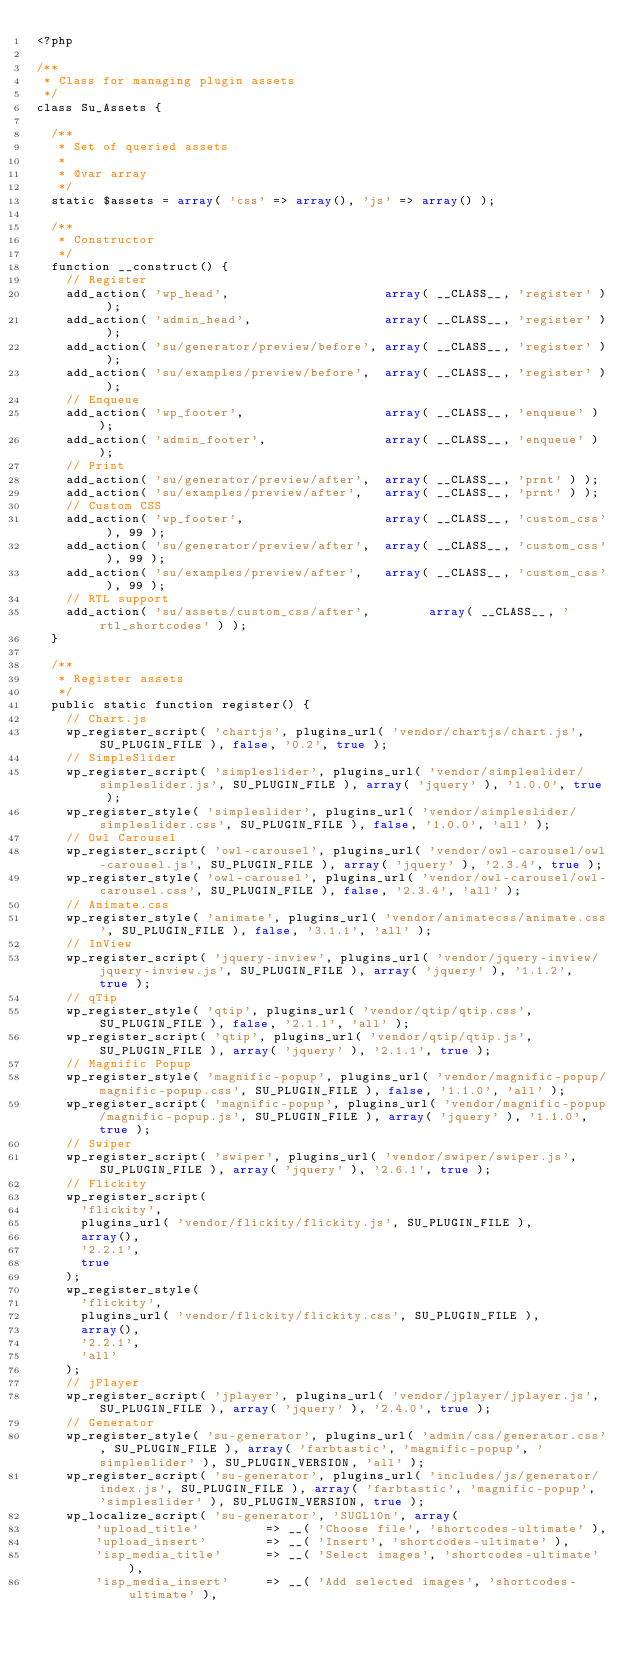<code> <loc_0><loc_0><loc_500><loc_500><_PHP_><?php

/**
 * Class for managing plugin assets
 */
class Su_Assets {

	/**
	 * Set of queried assets
	 *
	 * @var array
	 */
	static $assets = array( 'css' => array(), 'js' => array() );

	/**
	 * Constructor
	 */
	function __construct() {
		// Register
		add_action( 'wp_head',                     array( __CLASS__, 'register' ) );
		add_action( 'admin_head',                  array( __CLASS__, 'register' ) );
		add_action( 'su/generator/preview/before', array( __CLASS__, 'register' ) );
		add_action( 'su/examples/preview/before',  array( __CLASS__, 'register' ) );
		// Enqueue
		add_action( 'wp_footer',                   array( __CLASS__, 'enqueue' ) );
		add_action( 'admin_footer',                array( __CLASS__, 'enqueue' ) );
		// Print
		add_action( 'su/generator/preview/after',  array( __CLASS__, 'prnt' ) );
		add_action( 'su/examples/preview/after',   array( __CLASS__, 'prnt' ) );
		// Custom CSS
		add_action( 'wp_footer',                   array( __CLASS__, 'custom_css' ), 99 );
		add_action( 'su/generator/preview/after',  array( __CLASS__, 'custom_css' ), 99 );
		add_action( 'su/examples/preview/after',   array( __CLASS__, 'custom_css' ), 99 );
		// RTL support
		add_action( 'su/assets/custom_css/after',        array( __CLASS__, 'rtl_shortcodes' ) );
	}

	/**
	 * Register assets
	 */
	public static function register() {
		// Chart.js
		wp_register_script( 'chartjs', plugins_url( 'vendor/chartjs/chart.js', SU_PLUGIN_FILE ), false, '0.2', true );
		// SimpleSlider
		wp_register_script( 'simpleslider', plugins_url( 'vendor/simpleslider/simpleslider.js', SU_PLUGIN_FILE ), array( 'jquery' ), '1.0.0', true );
		wp_register_style( 'simpleslider', plugins_url( 'vendor/simpleslider/simpleslider.css', SU_PLUGIN_FILE ), false, '1.0.0', 'all' );
		// Owl Carousel
		wp_register_script( 'owl-carousel', plugins_url( 'vendor/owl-carousel/owl-carousel.js', SU_PLUGIN_FILE ), array( 'jquery' ), '2.3.4', true );
		wp_register_style( 'owl-carousel', plugins_url( 'vendor/owl-carousel/owl-carousel.css', SU_PLUGIN_FILE ), false, '2.3.4', 'all' );
		// Animate.css
		wp_register_style( 'animate', plugins_url( 'vendor/animatecss/animate.css', SU_PLUGIN_FILE ), false, '3.1.1', 'all' );
		// InView
		wp_register_script( 'jquery-inview', plugins_url( 'vendor/jquery-inview/jquery-inview.js', SU_PLUGIN_FILE ), array( 'jquery' ), '1.1.2', true );
		// qTip
		wp_register_style( 'qtip', plugins_url( 'vendor/qtip/qtip.css', SU_PLUGIN_FILE ), false, '2.1.1', 'all' );
		wp_register_script( 'qtip', plugins_url( 'vendor/qtip/qtip.js', SU_PLUGIN_FILE ), array( 'jquery' ), '2.1.1', true );
		// Magnific Popup
		wp_register_style( 'magnific-popup', plugins_url( 'vendor/magnific-popup/magnific-popup.css', SU_PLUGIN_FILE ), false, '1.1.0', 'all' );
		wp_register_script( 'magnific-popup', plugins_url( 'vendor/magnific-popup/magnific-popup.js', SU_PLUGIN_FILE ), array( 'jquery' ), '1.1.0', true );
		// Swiper
		wp_register_script( 'swiper', plugins_url( 'vendor/swiper/swiper.js', SU_PLUGIN_FILE ), array( 'jquery' ), '2.6.1', true );
		// Flickity
		wp_register_script(
			'flickity',
			plugins_url( 'vendor/flickity/flickity.js', SU_PLUGIN_FILE ),
			array(),
			'2.2.1',
			true
		);
		wp_register_style(
			'flickity',
			plugins_url( 'vendor/flickity/flickity.css', SU_PLUGIN_FILE ),
			array(),
			'2.2.1',
			'all'
		);
		// jPlayer
		wp_register_script( 'jplayer', plugins_url( 'vendor/jplayer/jplayer.js', SU_PLUGIN_FILE ), array( 'jquery' ), '2.4.0', true );
		// Generator
		wp_register_style( 'su-generator', plugins_url( 'admin/css/generator.css', SU_PLUGIN_FILE ), array( 'farbtastic', 'magnific-popup', 'simpleslider' ), SU_PLUGIN_VERSION, 'all' );
		wp_register_script( 'su-generator', plugins_url( 'includes/js/generator/index.js', SU_PLUGIN_FILE ), array( 'farbtastic', 'magnific-popup', 'simpleslider' ), SU_PLUGIN_VERSION, true );
		wp_localize_script( 'su-generator', 'SUGL10n', array(
				'upload_title'         => __( 'Choose file', 'shortcodes-ultimate' ),
				'upload_insert'        => __( 'Insert', 'shortcodes-ultimate' ),
				'isp_media_title'      => __( 'Select images', 'shortcodes-ultimate' ),
				'isp_media_insert'     => __( 'Add selected images', 'shortcodes-ultimate' ),</code> 